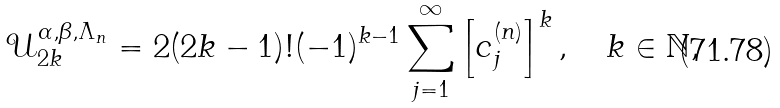Convert formula to latex. <formula><loc_0><loc_0><loc_500><loc_500>\mathcal { U } _ { 2 k } ^ { \alpha , \beta , \Lambda _ { n } } = 2 ( 2 k - 1 ) ! ( - 1 ) ^ { k - 1 } \sum _ { j = 1 } ^ { \infty } \left [ c _ { j } ^ { ( n ) } \right ] ^ { k } , \quad k \in \mathbb { N } ,</formula> 